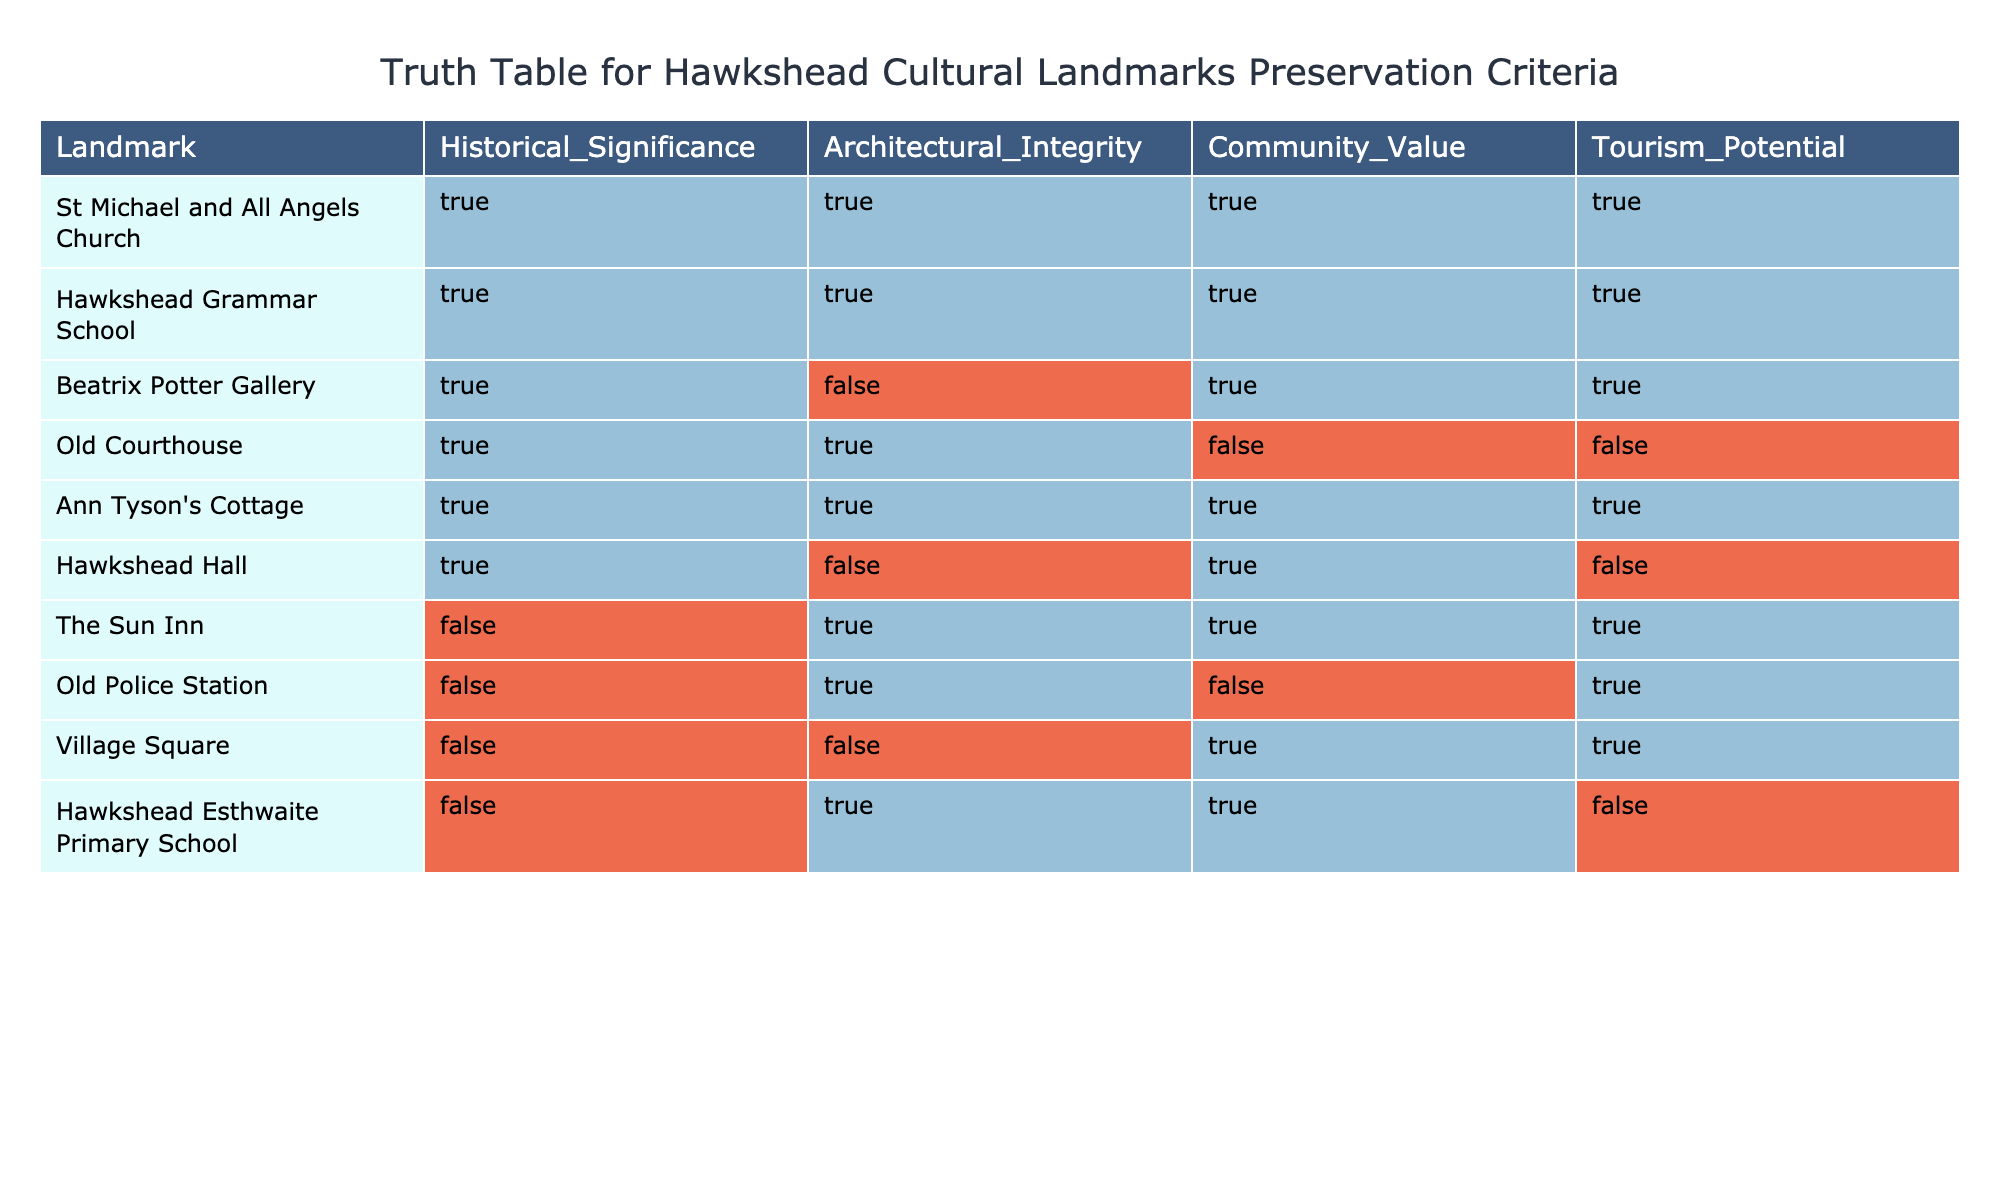What is the tourism potential of Ann Tyson's Cottage? The table indicates that Ann Tyson's Cottage has a tourism potential of TRUE. This means it is perceived as a valuable site for attracting visitors.
Answer: TRUE How many landmarks have both historical significance and architectural integrity? From the table, we can count the landmarks that have both historical significance (TRUE) and architectural integrity (TRUE). These are St Michael and All Angels Church, Hawkshead Grammar School, Old Courthouse, and Ann Tyson's Cottage, totaling four landmarks.
Answer: 4 Is the Beatrix Potter Gallery considered to have architectural integrity? The table specifies that the Beatrix Potter Gallery has an architectural integrity value of FALSE. This indicates that it may not meet the criteria for architectural preservation in this context.
Answer: FALSE Which landmark has the lowest score in terms of community value? Looking at the table, the Old Courthouse has a community value of FALSE, which is the lowest score compared to other landmarks.
Answer: Old Courthouse Calculate the average tourism potential for all the landmarks listed in the table. To calculate the average tourism potential, we convert TRUE to 1 and FALSE to 0. The values for tourism potential are TRUE, TRUE, TRUE, FALSE, TRUE, FALSE, TRUE, TRUE, TRUE, and FALSE. This gives us a sum of 7 and a total of 10 landmarks, so the average is 7/10 = 0.7 or 70%.
Answer: 70% Does Hawkshead Hall have community value? The table indicates that Hawkshead Hall has a community value of FALSE, meaning it is not regarded as a site of community importance.
Answer: FALSE Identify the landmark with both historical significance and community value but lacking architectural integrity. The Old Courthouse fits this description, as it has both historical significance (TRUE) and community value (FALSE), but lacks architectural integrity (TRUE).
Answer: Old Courthouse How many landmarks have a historical significance value of FALSE? By reviewing the table, it shows that The Sun Inn, Old Police Station, Village Square, and Hawkshead Esthwaite Primary School all have a historical significance of FALSE. This equals four landmarks.
Answer: 4 